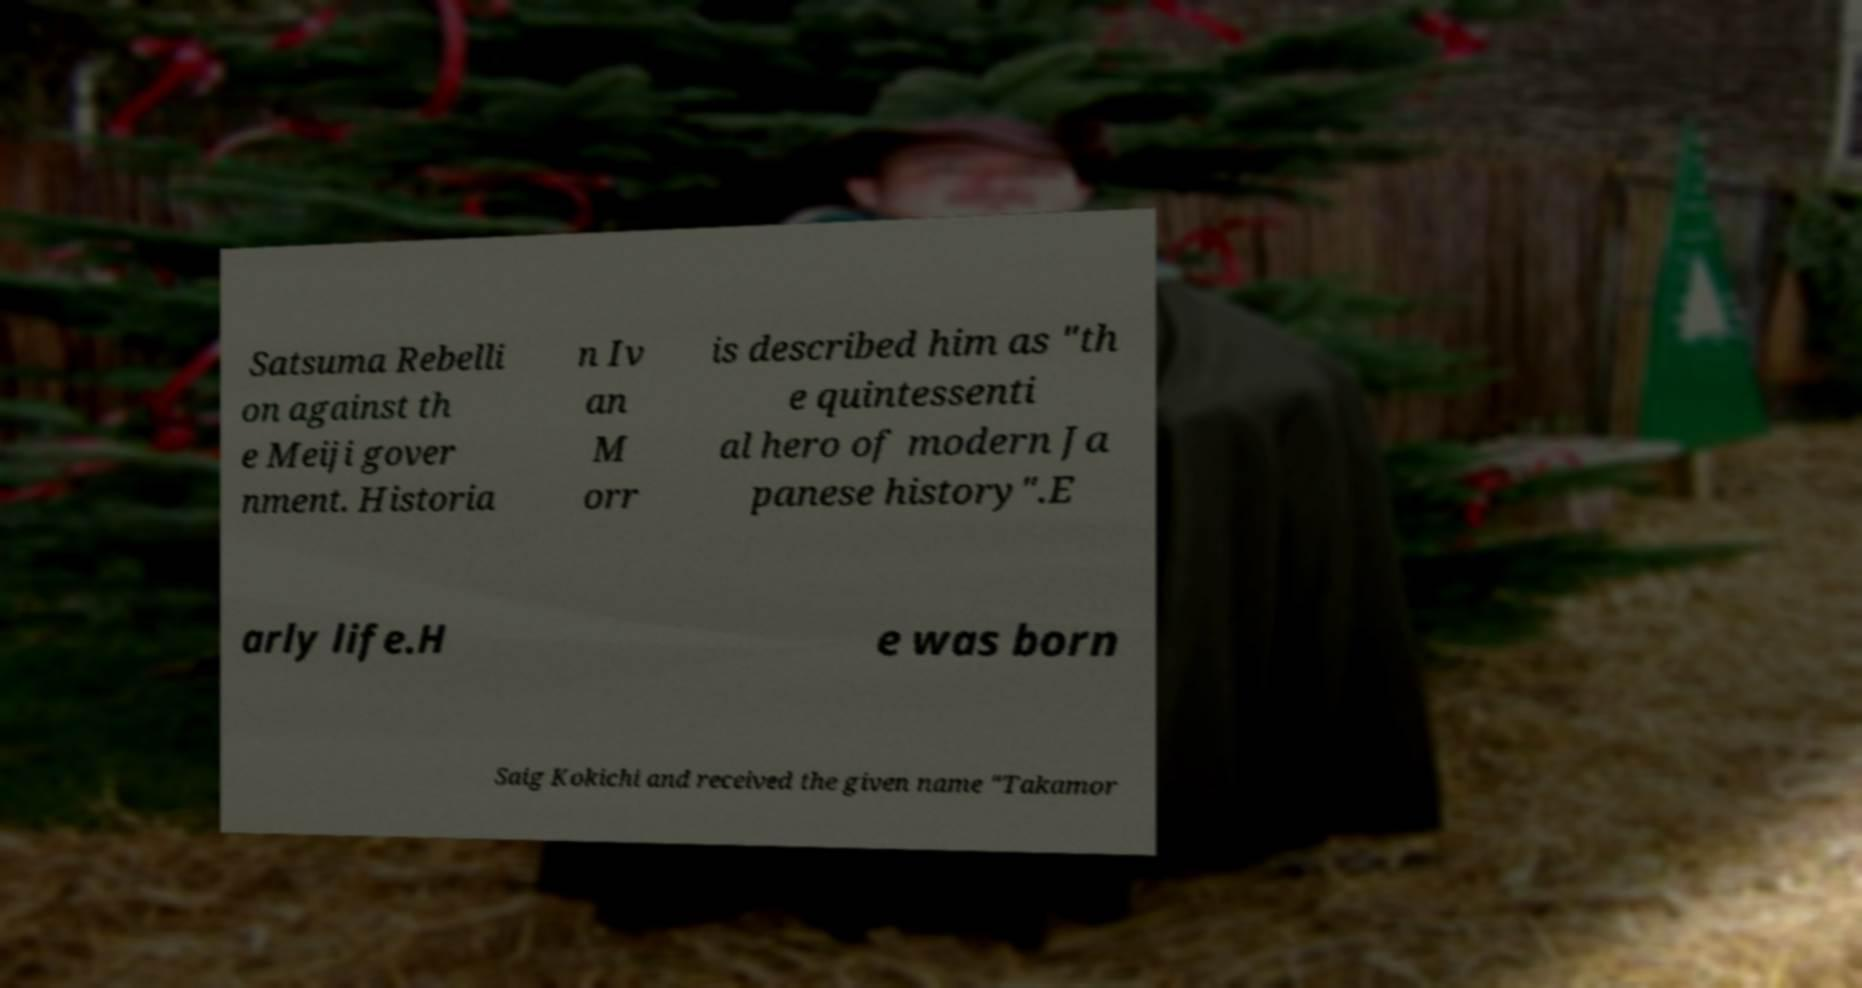What messages or text are displayed in this image? I need them in a readable, typed format. Satsuma Rebelli on against th e Meiji gover nment. Historia n Iv an M orr is described him as "th e quintessenti al hero of modern Ja panese history".E arly life.H e was born Saig Kokichi and received the given name "Takamor 